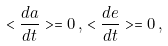<formula> <loc_0><loc_0><loc_500><loc_500>< \frac { d a } { d t } > = 0 \, , \, < \frac { d e } { d t } > = 0 \, ,</formula> 